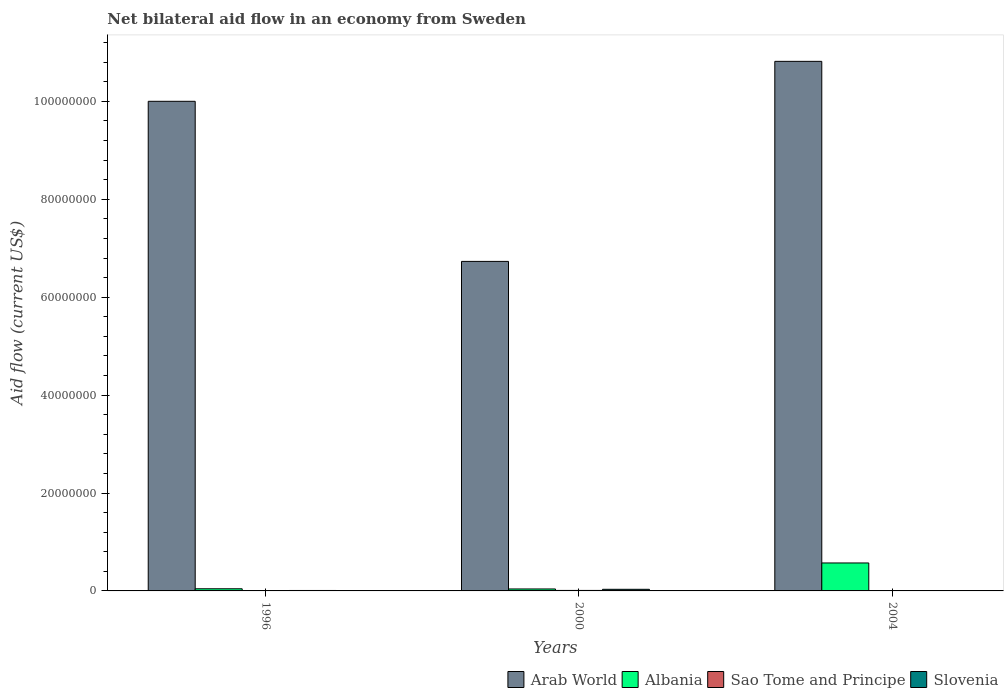How many bars are there on the 1st tick from the left?
Offer a very short reply. 4. What is the label of the 3rd group of bars from the left?
Your answer should be compact. 2004. In how many cases, is the number of bars for a given year not equal to the number of legend labels?
Provide a succinct answer. 0. What is the net bilateral aid flow in Sao Tome and Principe in 1996?
Give a very brief answer. 8.00e+04. Across all years, what is the maximum net bilateral aid flow in Sao Tome and Principe?
Ensure brevity in your answer.  1.00e+05. Across all years, what is the minimum net bilateral aid flow in Arab World?
Give a very brief answer. 6.73e+07. In which year was the net bilateral aid flow in Sao Tome and Principe maximum?
Offer a terse response. 2000. In which year was the net bilateral aid flow in Albania minimum?
Provide a succinct answer. 2000. What is the total net bilateral aid flow in Arab World in the graph?
Your answer should be compact. 2.75e+08. What is the difference between the net bilateral aid flow in Sao Tome and Principe in 2000 and that in 2004?
Provide a short and direct response. 8.00e+04. What is the difference between the net bilateral aid flow in Albania in 1996 and the net bilateral aid flow in Sao Tome and Principe in 2004?
Ensure brevity in your answer.  4.20e+05. What is the average net bilateral aid flow in Arab World per year?
Offer a very short reply. 9.18e+07. In the year 2004, what is the difference between the net bilateral aid flow in Arab World and net bilateral aid flow in Sao Tome and Principe?
Ensure brevity in your answer.  1.08e+08. What is the ratio of the net bilateral aid flow in Arab World in 2000 to that in 2004?
Provide a succinct answer. 0.62. Is the net bilateral aid flow in Sao Tome and Principe in 2000 less than that in 2004?
Make the answer very short. No. What is the difference between the highest and the second highest net bilateral aid flow in Albania?
Give a very brief answer. 5.27e+06. What is the difference between the highest and the lowest net bilateral aid flow in Albania?
Give a very brief answer. 5.31e+06. Is the sum of the net bilateral aid flow in Albania in 1996 and 2000 greater than the maximum net bilateral aid flow in Slovenia across all years?
Your answer should be compact. Yes. What does the 1st bar from the left in 2004 represents?
Ensure brevity in your answer.  Arab World. What does the 4th bar from the right in 2004 represents?
Ensure brevity in your answer.  Arab World. Is it the case that in every year, the sum of the net bilateral aid flow in Slovenia and net bilateral aid flow in Albania is greater than the net bilateral aid flow in Sao Tome and Principe?
Provide a short and direct response. Yes. How many years are there in the graph?
Provide a short and direct response. 3. Are the values on the major ticks of Y-axis written in scientific E-notation?
Offer a terse response. No. Does the graph contain any zero values?
Provide a short and direct response. No. Does the graph contain grids?
Ensure brevity in your answer.  No. What is the title of the graph?
Provide a succinct answer. Net bilateral aid flow in an economy from Sweden. What is the label or title of the Y-axis?
Ensure brevity in your answer.  Aid flow (current US$). What is the Aid flow (current US$) in Arab World in 1996?
Provide a short and direct response. 1.00e+08. What is the Aid flow (current US$) in Sao Tome and Principe in 1996?
Your answer should be compact. 8.00e+04. What is the Aid flow (current US$) of Slovenia in 1996?
Offer a terse response. 9.00e+04. What is the Aid flow (current US$) in Arab World in 2000?
Your response must be concise. 6.73e+07. What is the Aid flow (current US$) of Albania in 2000?
Give a very brief answer. 4.00e+05. What is the Aid flow (current US$) of Slovenia in 2000?
Provide a succinct answer. 3.30e+05. What is the Aid flow (current US$) in Arab World in 2004?
Provide a short and direct response. 1.08e+08. What is the Aid flow (current US$) in Albania in 2004?
Ensure brevity in your answer.  5.71e+06. Across all years, what is the maximum Aid flow (current US$) of Arab World?
Make the answer very short. 1.08e+08. Across all years, what is the maximum Aid flow (current US$) in Albania?
Make the answer very short. 5.71e+06. Across all years, what is the maximum Aid flow (current US$) of Sao Tome and Principe?
Offer a very short reply. 1.00e+05. Across all years, what is the maximum Aid flow (current US$) in Slovenia?
Make the answer very short. 3.30e+05. Across all years, what is the minimum Aid flow (current US$) of Arab World?
Ensure brevity in your answer.  6.73e+07. Across all years, what is the minimum Aid flow (current US$) of Albania?
Your response must be concise. 4.00e+05. What is the total Aid flow (current US$) of Arab World in the graph?
Make the answer very short. 2.75e+08. What is the total Aid flow (current US$) of Albania in the graph?
Make the answer very short. 6.55e+06. What is the total Aid flow (current US$) in Sao Tome and Principe in the graph?
Provide a succinct answer. 2.00e+05. What is the total Aid flow (current US$) of Slovenia in the graph?
Give a very brief answer. 4.90e+05. What is the difference between the Aid flow (current US$) in Arab World in 1996 and that in 2000?
Your answer should be compact. 3.27e+07. What is the difference between the Aid flow (current US$) of Albania in 1996 and that in 2000?
Provide a short and direct response. 4.00e+04. What is the difference between the Aid flow (current US$) of Sao Tome and Principe in 1996 and that in 2000?
Provide a succinct answer. -2.00e+04. What is the difference between the Aid flow (current US$) of Arab World in 1996 and that in 2004?
Offer a very short reply. -8.16e+06. What is the difference between the Aid flow (current US$) of Albania in 1996 and that in 2004?
Make the answer very short. -5.27e+06. What is the difference between the Aid flow (current US$) of Sao Tome and Principe in 1996 and that in 2004?
Your response must be concise. 6.00e+04. What is the difference between the Aid flow (current US$) in Arab World in 2000 and that in 2004?
Your answer should be very brief. -4.09e+07. What is the difference between the Aid flow (current US$) of Albania in 2000 and that in 2004?
Provide a succinct answer. -5.31e+06. What is the difference between the Aid flow (current US$) in Slovenia in 2000 and that in 2004?
Ensure brevity in your answer.  2.60e+05. What is the difference between the Aid flow (current US$) in Arab World in 1996 and the Aid flow (current US$) in Albania in 2000?
Provide a short and direct response. 9.96e+07. What is the difference between the Aid flow (current US$) of Arab World in 1996 and the Aid flow (current US$) of Sao Tome and Principe in 2000?
Offer a terse response. 9.99e+07. What is the difference between the Aid flow (current US$) in Arab World in 1996 and the Aid flow (current US$) in Slovenia in 2000?
Provide a succinct answer. 9.97e+07. What is the difference between the Aid flow (current US$) in Arab World in 1996 and the Aid flow (current US$) in Albania in 2004?
Offer a terse response. 9.43e+07. What is the difference between the Aid flow (current US$) of Arab World in 1996 and the Aid flow (current US$) of Sao Tome and Principe in 2004?
Offer a very short reply. 1.00e+08. What is the difference between the Aid flow (current US$) in Arab World in 1996 and the Aid flow (current US$) in Slovenia in 2004?
Offer a terse response. 9.99e+07. What is the difference between the Aid flow (current US$) in Albania in 1996 and the Aid flow (current US$) in Sao Tome and Principe in 2004?
Make the answer very short. 4.20e+05. What is the difference between the Aid flow (current US$) in Albania in 1996 and the Aid flow (current US$) in Slovenia in 2004?
Your response must be concise. 3.70e+05. What is the difference between the Aid flow (current US$) of Arab World in 2000 and the Aid flow (current US$) of Albania in 2004?
Make the answer very short. 6.16e+07. What is the difference between the Aid flow (current US$) of Arab World in 2000 and the Aid flow (current US$) of Sao Tome and Principe in 2004?
Provide a short and direct response. 6.73e+07. What is the difference between the Aid flow (current US$) of Arab World in 2000 and the Aid flow (current US$) of Slovenia in 2004?
Your answer should be compact. 6.72e+07. What is the difference between the Aid flow (current US$) in Albania in 2000 and the Aid flow (current US$) in Slovenia in 2004?
Make the answer very short. 3.30e+05. What is the average Aid flow (current US$) in Arab World per year?
Ensure brevity in your answer.  9.18e+07. What is the average Aid flow (current US$) of Albania per year?
Ensure brevity in your answer.  2.18e+06. What is the average Aid flow (current US$) of Sao Tome and Principe per year?
Offer a very short reply. 6.67e+04. What is the average Aid flow (current US$) of Slovenia per year?
Ensure brevity in your answer.  1.63e+05. In the year 1996, what is the difference between the Aid flow (current US$) of Arab World and Aid flow (current US$) of Albania?
Provide a short and direct response. 9.96e+07. In the year 1996, what is the difference between the Aid flow (current US$) in Arab World and Aid flow (current US$) in Sao Tome and Principe?
Make the answer very short. 9.99e+07. In the year 1996, what is the difference between the Aid flow (current US$) in Arab World and Aid flow (current US$) in Slovenia?
Give a very brief answer. 9.99e+07. In the year 1996, what is the difference between the Aid flow (current US$) of Albania and Aid flow (current US$) of Sao Tome and Principe?
Offer a very short reply. 3.60e+05. In the year 2000, what is the difference between the Aid flow (current US$) of Arab World and Aid flow (current US$) of Albania?
Your answer should be very brief. 6.69e+07. In the year 2000, what is the difference between the Aid flow (current US$) in Arab World and Aid flow (current US$) in Sao Tome and Principe?
Ensure brevity in your answer.  6.72e+07. In the year 2000, what is the difference between the Aid flow (current US$) of Arab World and Aid flow (current US$) of Slovenia?
Offer a terse response. 6.70e+07. In the year 2000, what is the difference between the Aid flow (current US$) of Albania and Aid flow (current US$) of Sao Tome and Principe?
Provide a short and direct response. 3.00e+05. In the year 2000, what is the difference between the Aid flow (current US$) of Sao Tome and Principe and Aid flow (current US$) of Slovenia?
Make the answer very short. -2.30e+05. In the year 2004, what is the difference between the Aid flow (current US$) of Arab World and Aid flow (current US$) of Albania?
Your answer should be very brief. 1.02e+08. In the year 2004, what is the difference between the Aid flow (current US$) in Arab World and Aid flow (current US$) in Sao Tome and Principe?
Ensure brevity in your answer.  1.08e+08. In the year 2004, what is the difference between the Aid flow (current US$) of Arab World and Aid flow (current US$) of Slovenia?
Offer a very short reply. 1.08e+08. In the year 2004, what is the difference between the Aid flow (current US$) in Albania and Aid flow (current US$) in Sao Tome and Principe?
Provide a short and direct response. 5.69e+06. In the year 2004, what is the difference between the Aid flow (current US$) in Albania and Aid flow (current US$) in Slovenia?
Your answer should be compact. 5.64e+06. What is the ratio of the Aid flow (current US$) in Arab World in 1996 to that in 2000?
Your response must be concise. 1.49. What is the ratio of the Aid flow (current US$) of Sao Tome and Principe in 1996 to that in 2000?
Offer a terse response. 0.8. What is the ratio of the Aid flow (current US$) in Slovenia in 1996 to that in 2000?
Make the answer very short. 0.27. What is the ratio of the Aid flow (current US$) of Arab World in 1996 to that in 2004?
Provide a short and direct response. 0.92. What is the ratio of the Aid flow (current US$) in Albania in 1996 to that in 2004?
Keep it short and to the point. 0.08. What is the ratio of the Aid flow (current US$) in Sao Tome and Principe in 1996 to that in 2004?
Offer a terse response. 4. What is the ratio of the Aid flow (current US$) of Arab World in 2000 to that in 2004?
Make the answer very short. 0.62. What is the ratio of the Aid flow (current US$) in Albania in 2000 to that in 2004?
Offer a terse response. 0.07. What is the ratio of the Aid flow (current US$) of Sao Tome and Principe in 2000 to that in 2004?
Provide a succinct answer. 5. What is the ratio of the Aid flow (current US$) of Slovenia in 2000 to that in 2004?
Offer a terse response. 4.71. What is the difference between the highest and the second highest Aid flow (current US$) in Arab World?
Keep it short and to the point. 8.16e+06. What is the difference between the highest and the second highest Aid flow (current US$) of Albania?
Your answer should be compact. 5.27e+06. What is the difference between the highest and the second highest Aid flow (current US$) in Slovenia?
Your answer should be very brief. 2.40e+05. What is the difference between the highest and the lowest Aid flow (current US$) of Arab World?
Provide a succinct answer. 4.09e+07. What is the difference between the highest and the lowest Aid flow (current US$) of Albania?
Provide a succinct answer. 5.31e+06. 